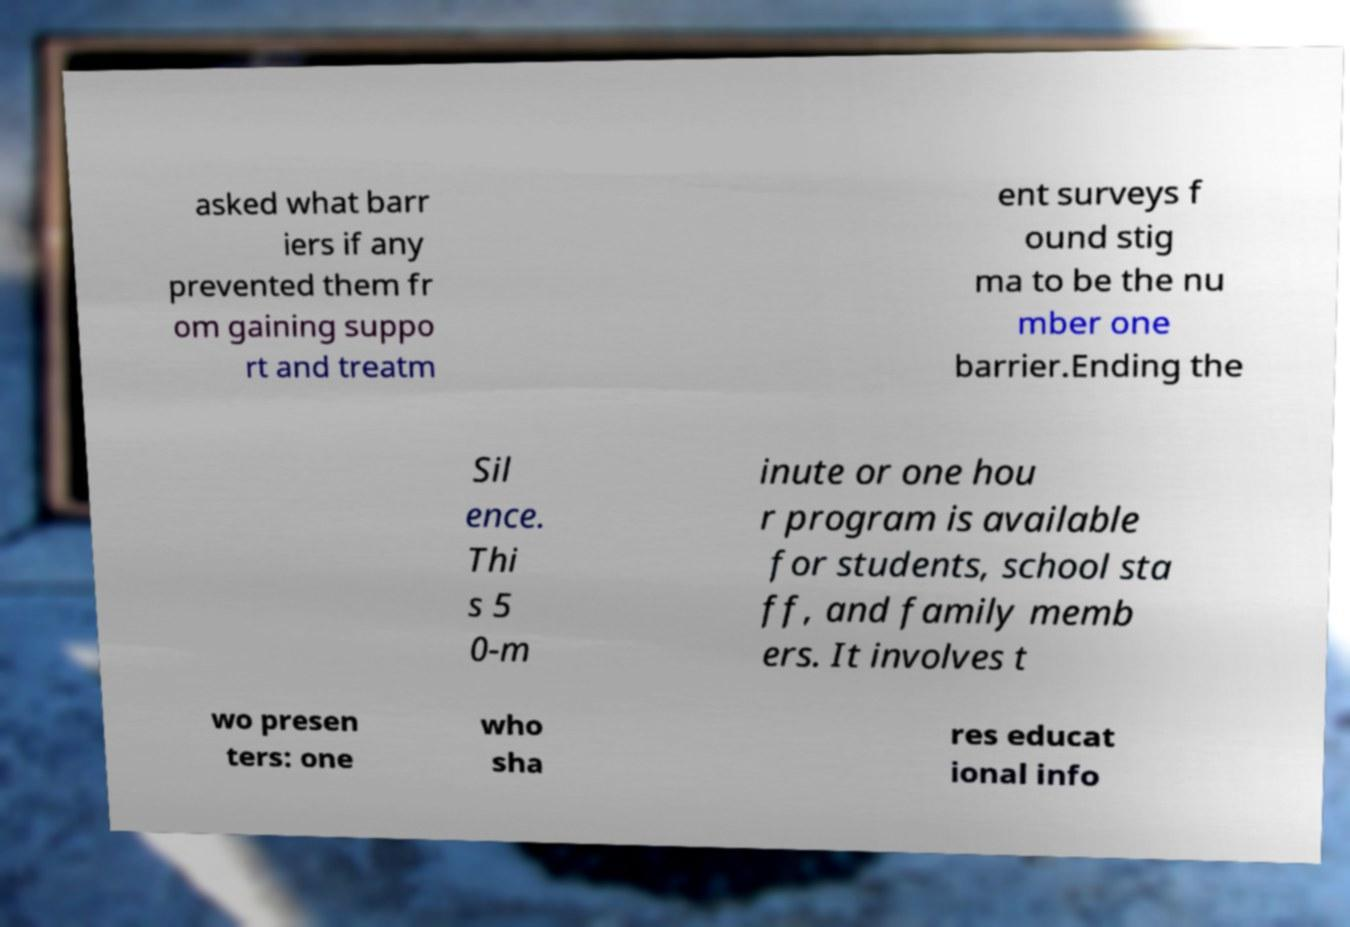Could you extract and type out the text from this image? asked what barr iers if any prevented them fr om gaining suppo rt and treatm ent surveys f ound stig ma to be the nu mber one barrier.Ending the Sil ence. Thi s 5 0-m inute or one hou r program is available for students, school sta ff, and family memb ers. It involves t wo presen ters: one who sha res educat ional info 